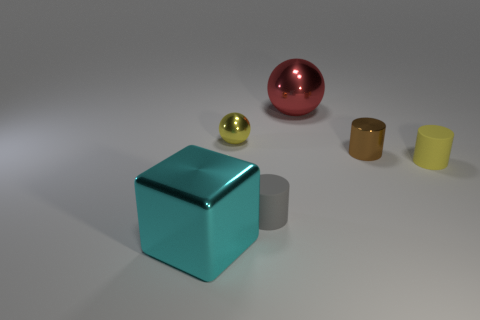Can you infer anything about the size of these objects? While there's no direct reference point for scale, the soft shadows and relative proportions of the objects suggest they are likely small, perhaps sized to fit comfortably within a human hand. Their diminutive size adds an element of delicacy to the scene and underscores their ornamental or illustrative nature. Based on that, where might you find these objects in a real-world setting? Given their size and aesthetic appeal, these objects could be decorative elements placed on a shelf, desk, or within a display cabinet. They might also serve as props in a still life composition for an artist or photographer, or be part of an educational toolkit for geometry lessons. 